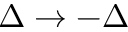<formula> <loc_0><loc_0><loc_500><loc_500>\Delta \rightarrow - \Delta</formula> 